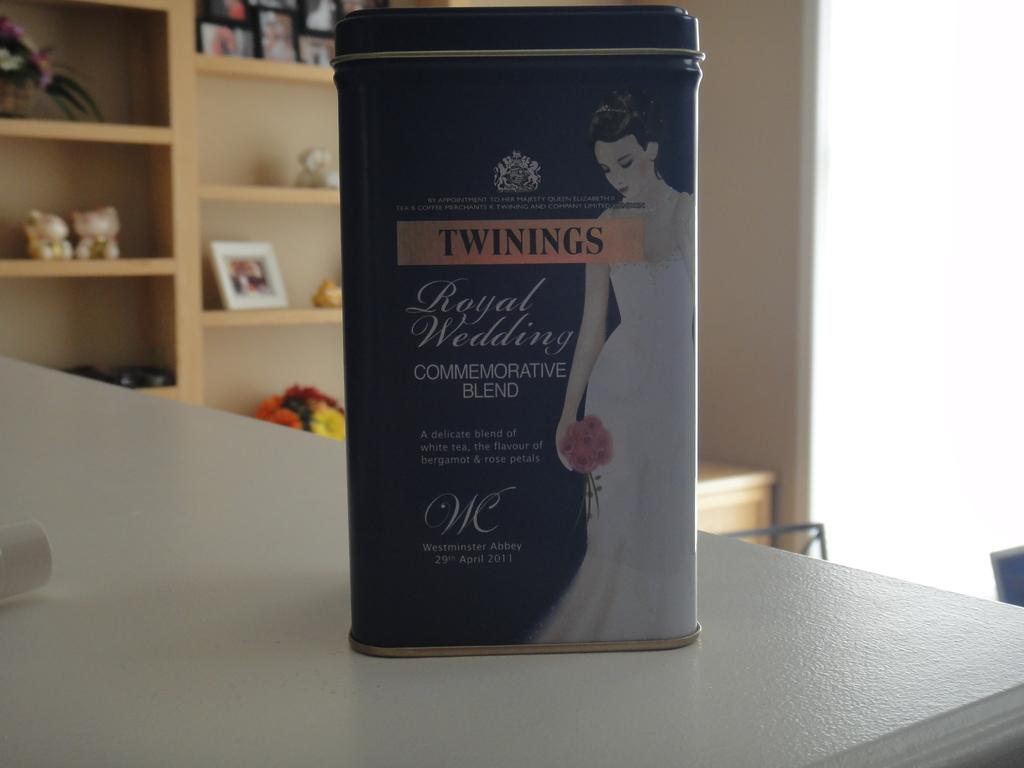<image>
Share a concise interpretation of the image provided. Box showing a bride on the box and says "Twinings". 